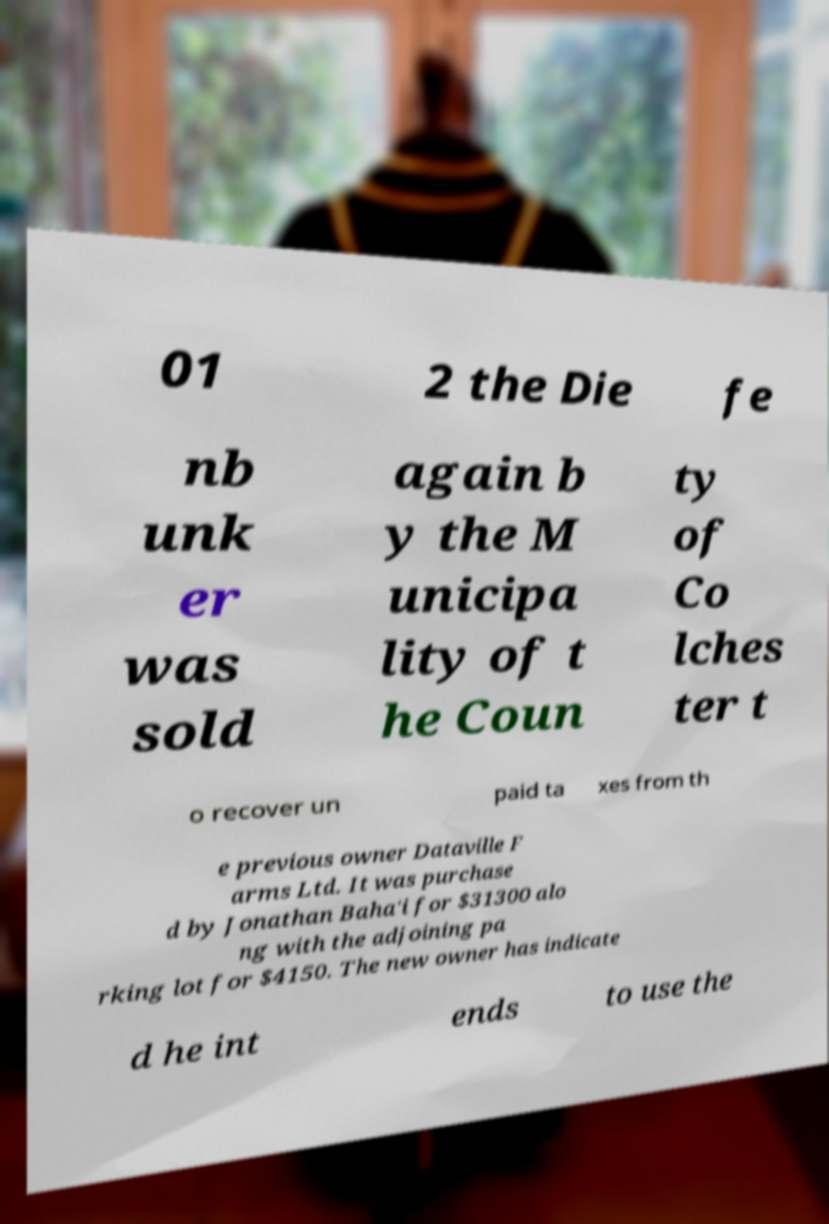I need the written content from this picture converted into text. Can you do that? 01 2 the Die fe nb unk er was sold again b y the M unicipa lity of t he Coun ty of Co lches ter t o recover un paid ta xes from th e previous owner Dataville F arms Ltd. It was purchase d by Jonathan Baha'i for $31300 alo ng with the adjoining pa rking lot for $4150. The new owner has indicate d he int ends to use the 